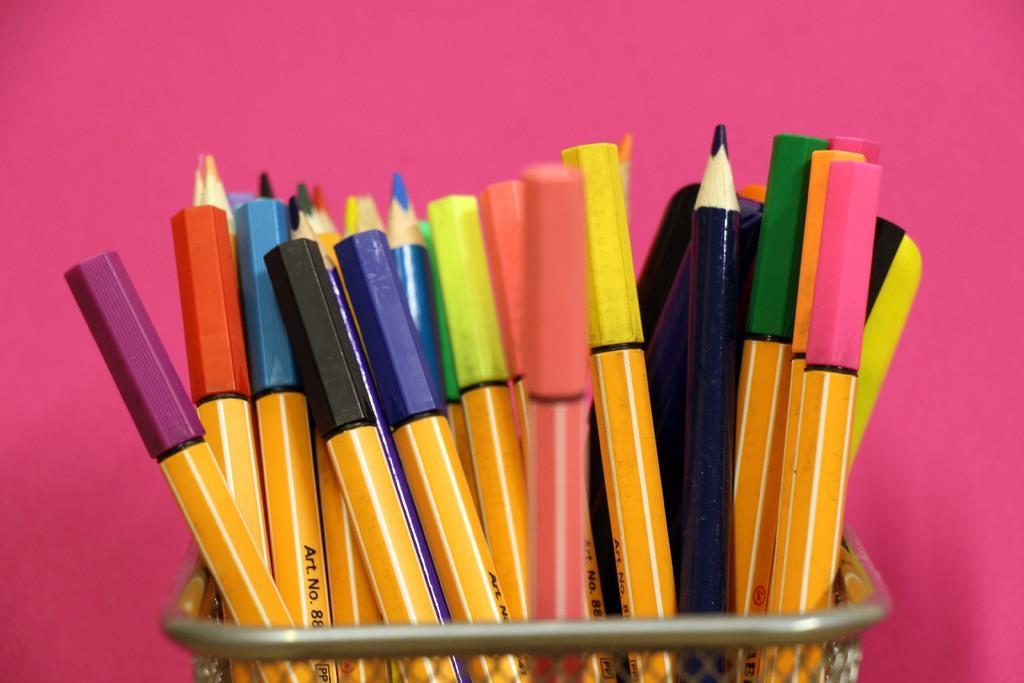In one or two sentences, can you explain what this image depicts? In this image I can see the metal pen pot and in it I can see few pens and pencils. I can see the pink colored background. 